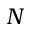<formula> <loc_0><loc_0><loc_500><loc_500>N</formula> 